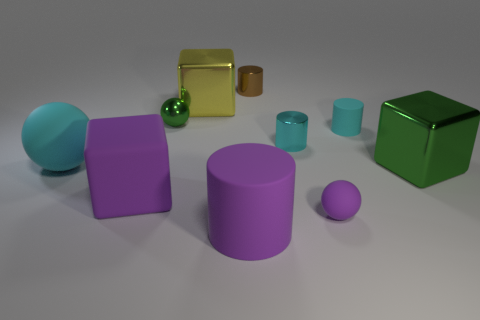Subtract all cyan cylinders. How many were subtracted if there are1cyan cylinders left? 1 Subtract all tiny cylinders. How many cylinders are left? 1 Subtract all cyan cylinders. How many cylinders are left? 2 Subtract all balls. How many objects are left? 7 Subtract all gray cylinders. Subtract all brown cubes. How many cylinders are left? 4 Subtract all large cylinders. Subtract all small red metal cubes. How many objects are left? 9 Add 7 purple spheres. How many purple spheres are left? 8 Add 7 cyan rubber balls. How many cyan rubber balls exist? 8 Subtract 0 red cylinders. How many objects are left? 10 Subtract 2 balls. How many balls are left? 1 